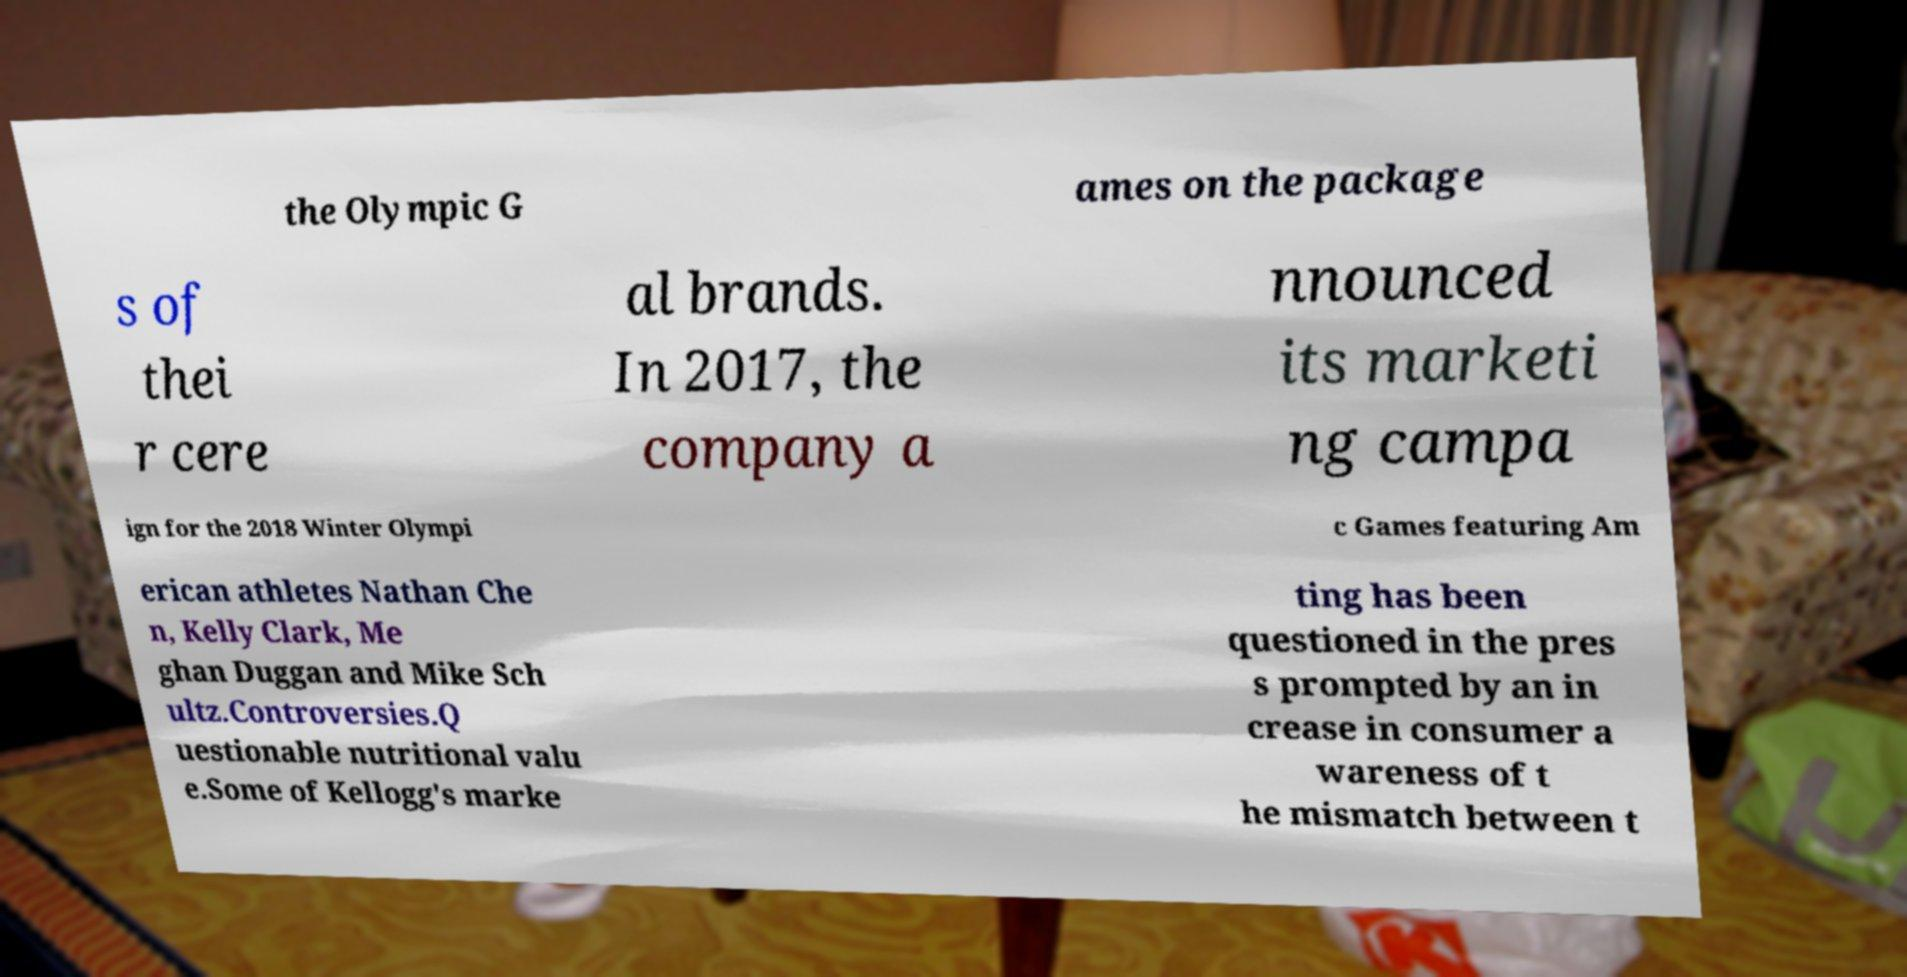For documentation purposes, I need the text within this image transcribed. Could you provide that? the Olympic G ames on the package s of thei r cere al brands. In 2017, the company a nnounced its marketi ng campa ign for the 2018 Winter Olympi c Games featuring Am erican athletes Nathan Che n, Kelly Clark, Me ghan Duggan and Mike Sch ultz.Controversies.Q uestionable nutritional valu e.Some of Kellogg's marke ting has been questioned in the pres s prompted by an in crease in consumer a wareness of t he mismatch between t 